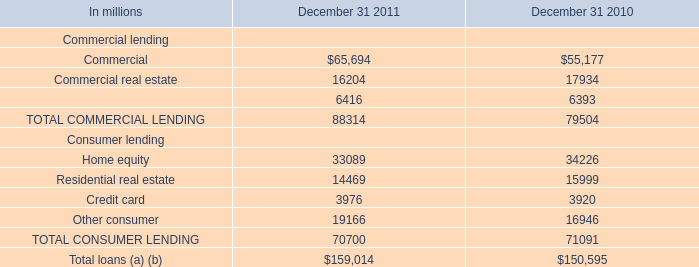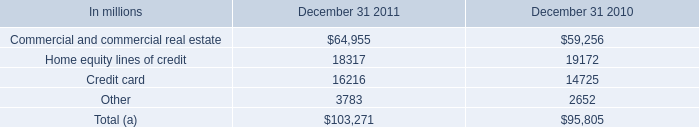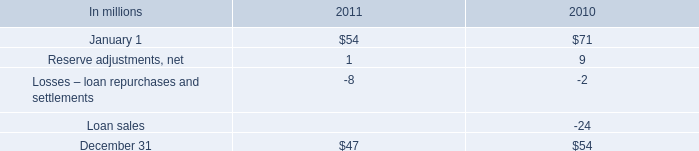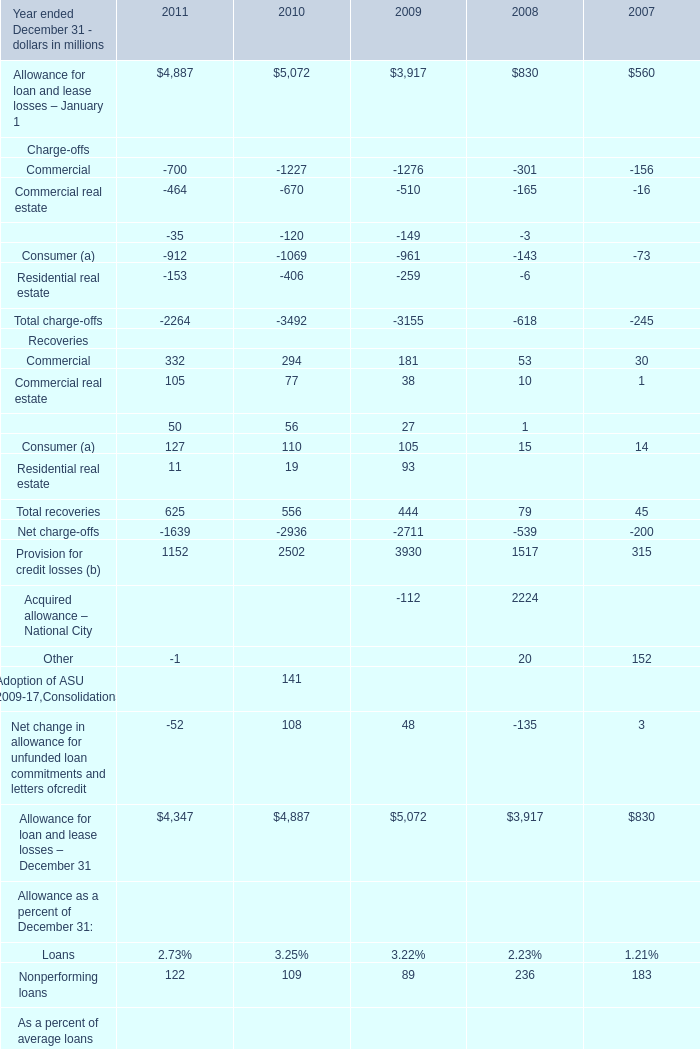during 2011 , what was the change in reserve for estimated losses included in other liabilities on our consolidated balance sheet? 
Computations: (54 - 47)
Answer: 7.0. 